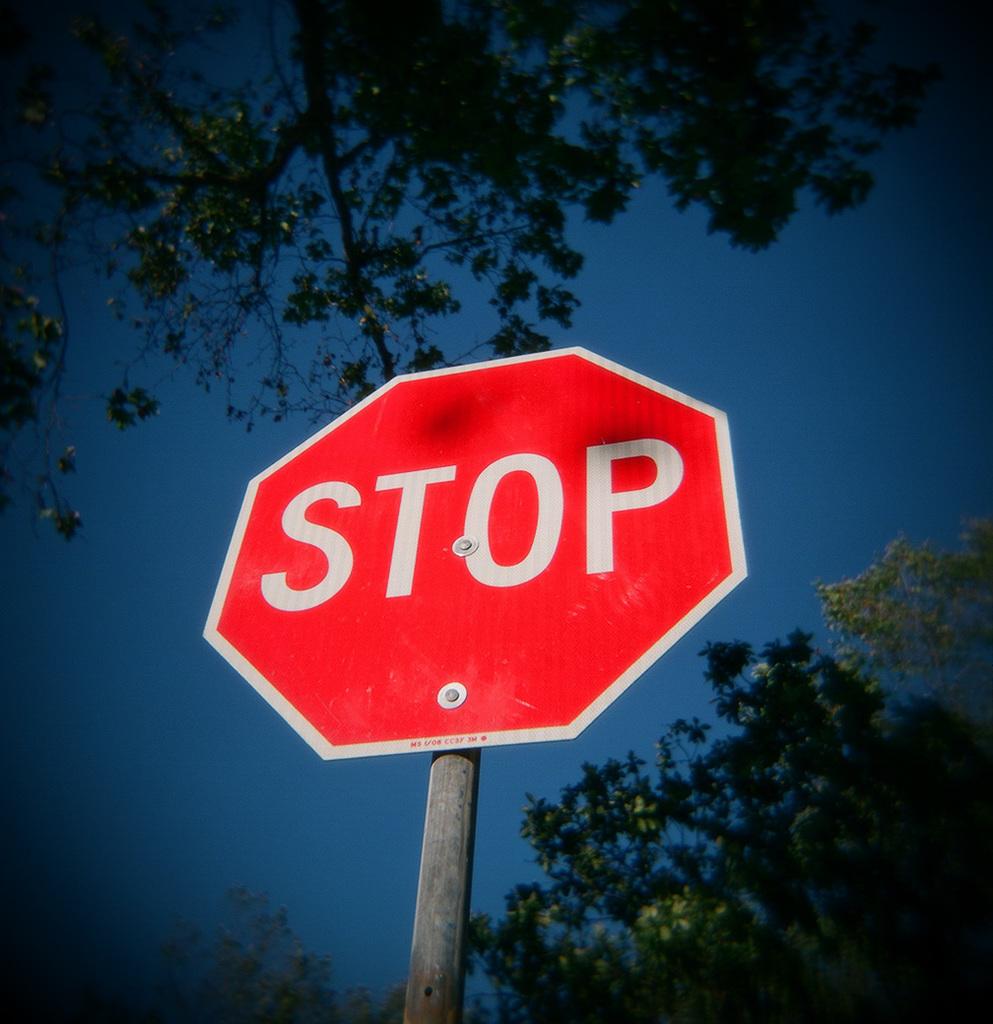What does the sign say?
Ensure brevity in your answer.  Stop. 